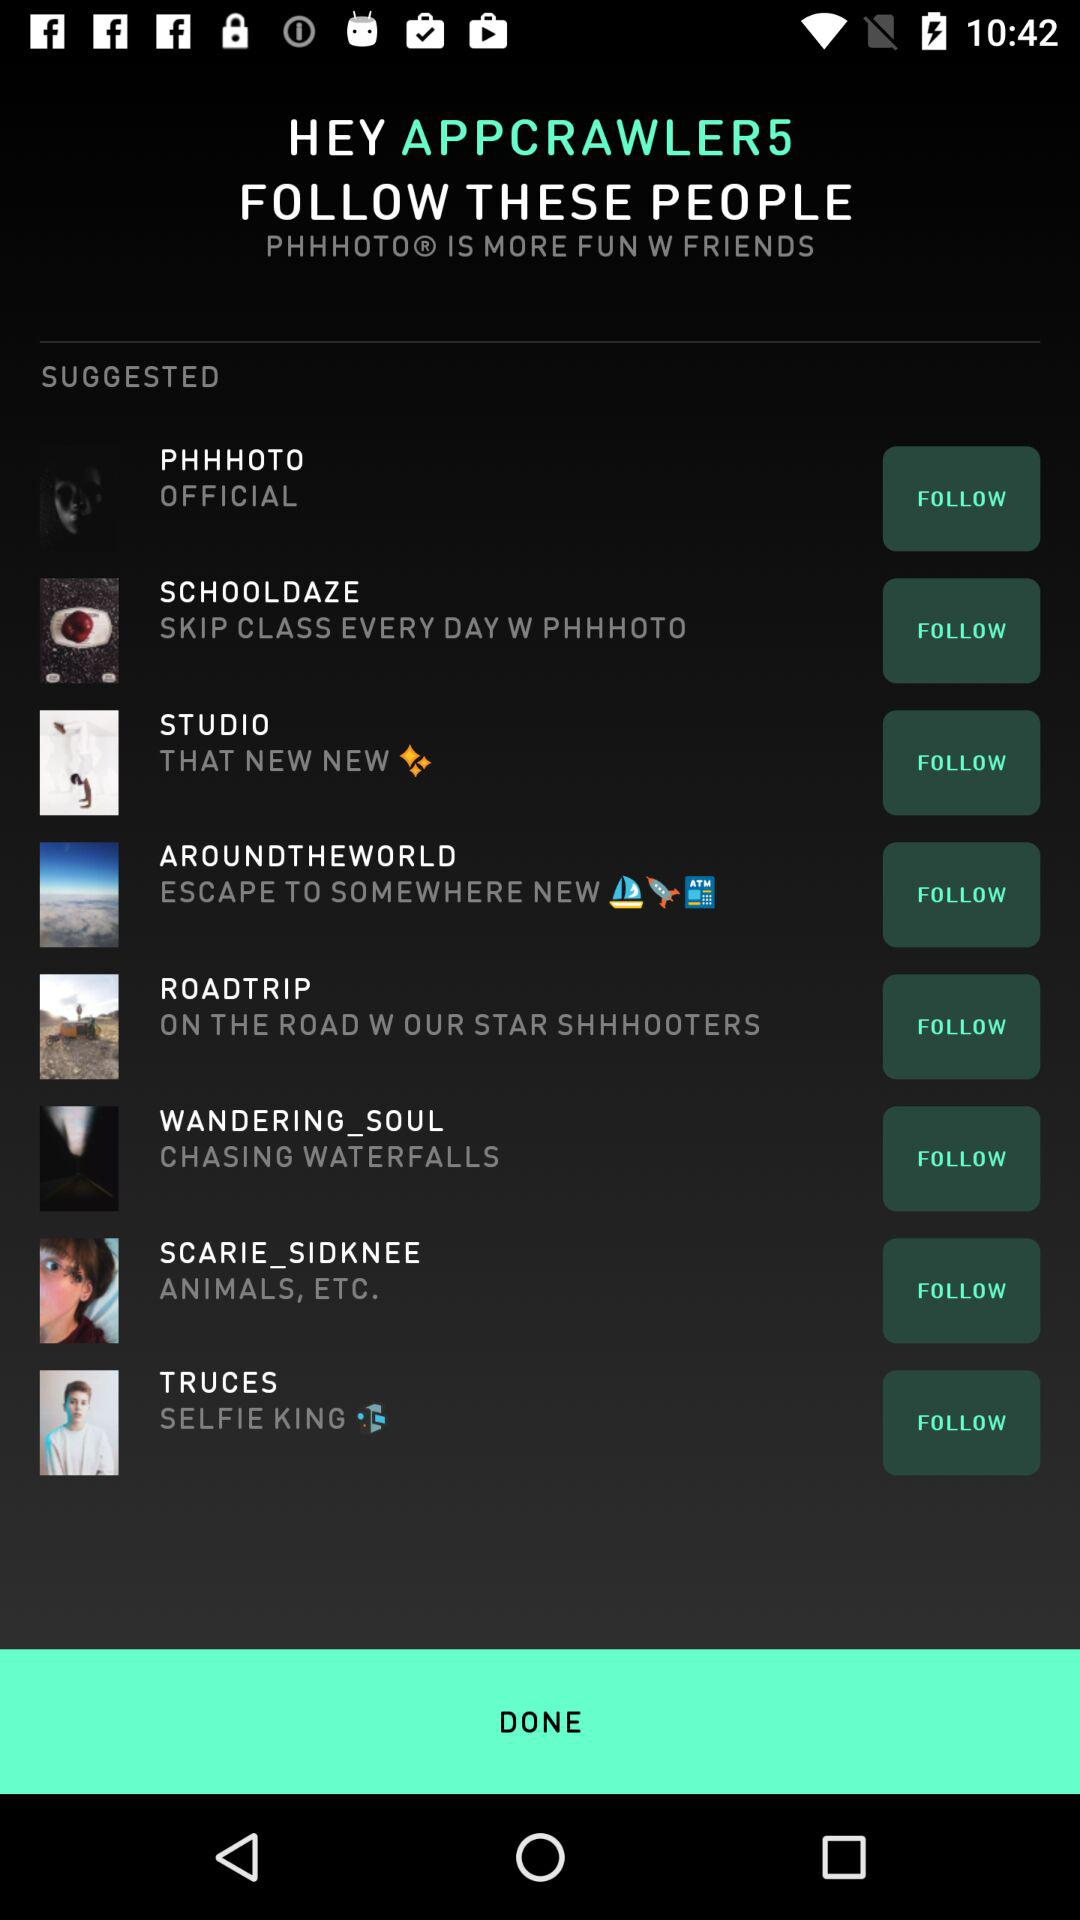What are the accounts that I can follow? The accounts are "PHHHOTO", "SCHOOLDAZE", "STUDIO", "AROUNDTHEWORLD", "ROADTRIP", "WANDERING_SOUL", "SCARIE_SIDKNEE" and "TRUCES". 